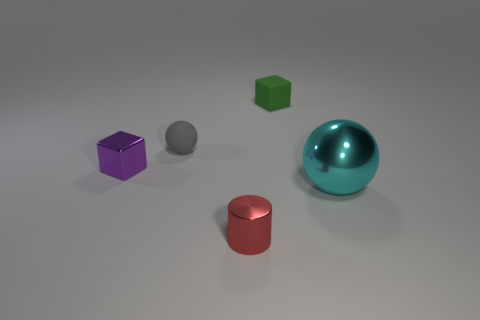Is there anything else that has the same shape as the tiny red thing?
Provide a short and direct response. No. Is the shape of the small red object the same as the small purple thing?
Keep it short and to the point. No. Are there an equal number of red metal cylinders that are on the right side of the tiny green cube and tiny rubber balls that are in front of the gray matte thing?
Ensure brevity in your answer.  Yes. What number of other objects are the same material as the tiny red object?
Provide a succinct answer. 2. What number of tiny objects are either red metal things or yellow blocks?
Keep it short and to the point. 1. Are there the same number of balls on the left side of the gray sphere and objects?
Offer a terse response. No. There is a small shiny thing in front of the cyan shiny object; are there any matte spheres that are in front of it?
Make the answer very short. No. What number of other things are there of the same color as the small sphere?
Your response must be concise. 0. What is the color of the big object?
Ensure brevity in your answer.  Cyan. What is the size of the object that is both on the right side of the small matte sphere and behind the big metal object?
Give a very brief answer. Small. 